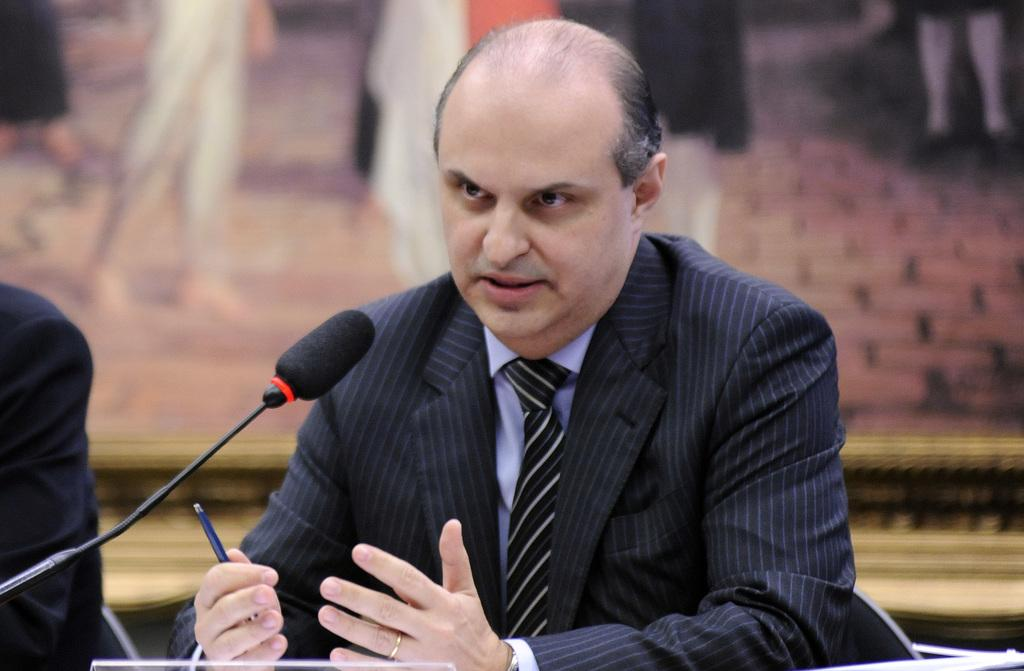What is the main subject of the image? There is a person in the image. What is the person wearing? The person is wearing a black colored blazer and a tie. What is the person doing in the image? The person is sitting and holding a pen. What object is in front of the person? There is a microphone in front of the person. How would you describe the background of the image? The background of the image is blurry. How does the person apply the brake while sitting in the image? There is no brake present in the image, as it is a person sitting and not a vehicle. What type of sugar is being used by the person in the image? There is no sugar present in the image; the person is holding a pen. 